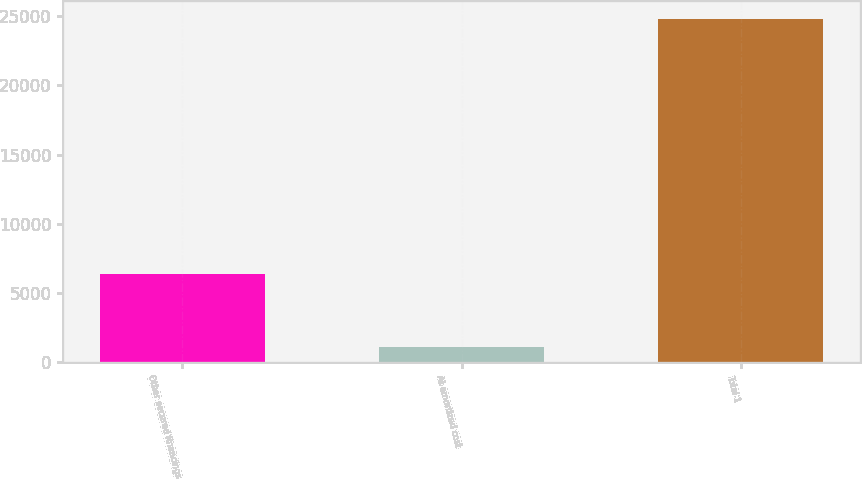Convert chart to OTSL. <chart><loc_0><loc_0><loc_500><loc_500><bar_chart><fcel>Other secured financings<fcel>At amortized cost<fcel>Total 1<nl><fcel>6389<fcel>1135<fcel>24814<nl></chart> 